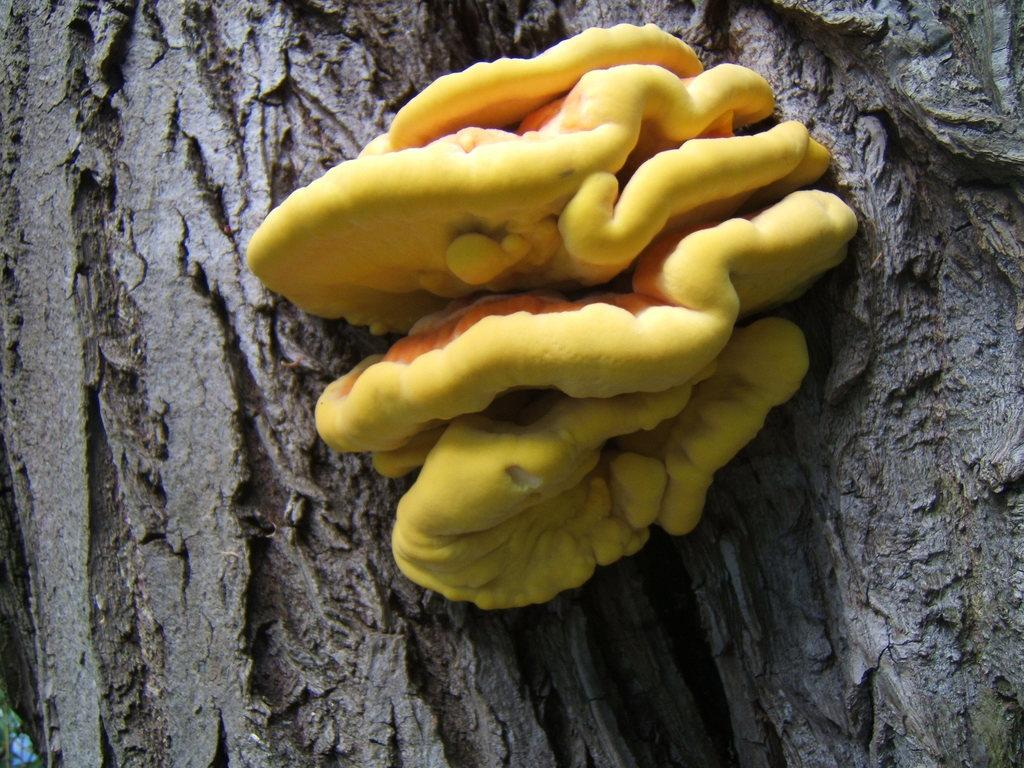What is the main subject of the image? The main subject of the image is a branch of a tree. What other objects can be seen in the image? There are mushrooms in the image. How do the mushrooms appear in the image? The mushrooms resemble flowers in the image. What color are the mushrooms? The mushrooms are yellow in color. Can you see any army personnel walking along the seashore in the image? There is no seashore or army personnel present in the image; it features a branch of a tree with mushrooms. Is there a brake visible on the branch in the image? There is no brake present in the image; it only shows a branch with mushrooms. 